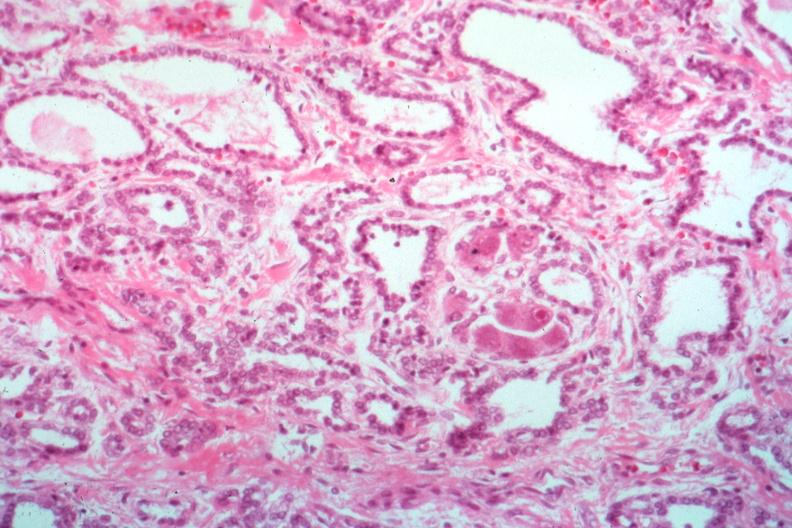what is present?
Answer the question using a single word or phrase. Cytomegalovirus 